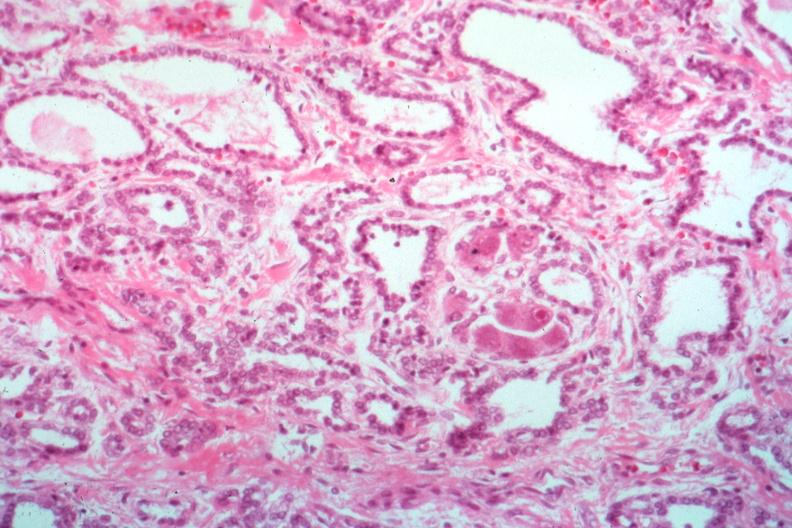what is present?
Answer the question using a single word or phrase. Cytomegalovirus 